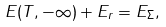<formula> <loc_0><loc_0><loc_500><loc_500>E ( T , - \infty ) + E _ { r } = E _ { \Sigma } ,</formula> 